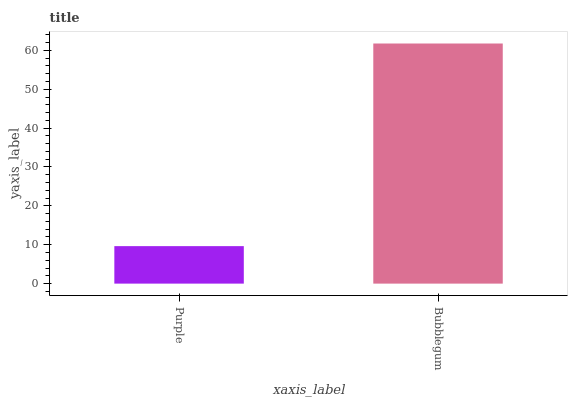Is Bubblegum the minimum?
Answer yes or no. No. Is Bubblegum greater than Purple?
Answer yes or no. Yes. Is Purple less than Bubblegum?
Answer yes or no. Yes. Is Purple greater than Bubblegum?
Answer yes or no. No. Is Bubblegum less than Purple?
Answer yes or no. No. Is Bubblegum the high median?
Answer yes or no. Yes. Is Purple the low median?
Answer yes or no. Yes. Is Purple the high median?
Answer yes or no. No. Is Bubblegum the low median?
Answer yes or no. No. 